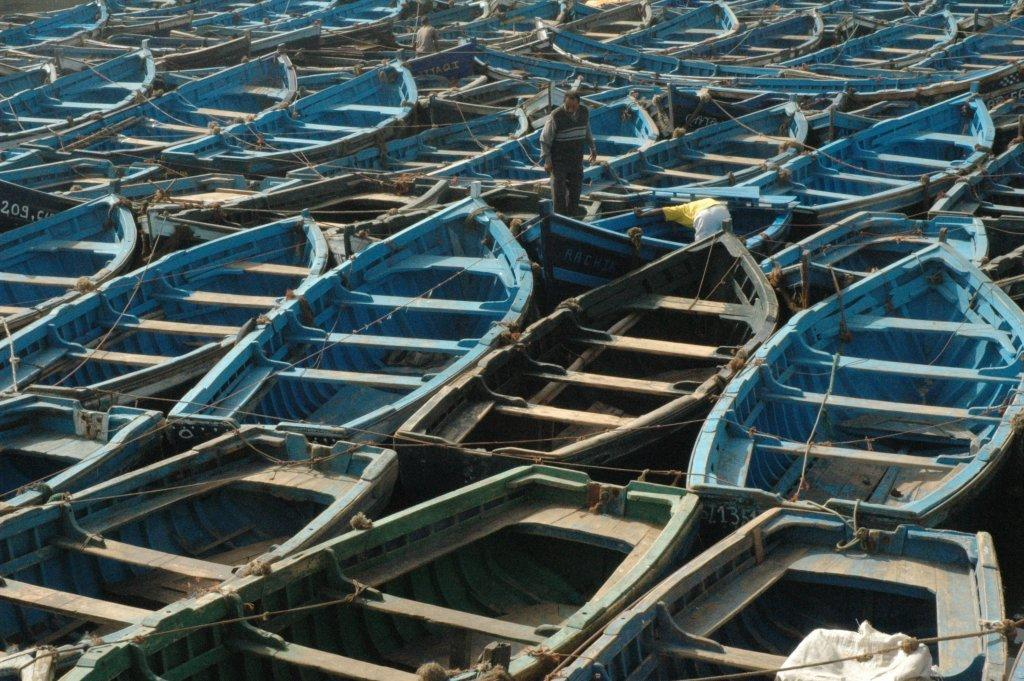What is the main subject of the image? The main subject of the image is many boats. What color are the boats in the image? The boats are blue in color. What material are the boats made of? The boats are made of wood. Can you describe the person in the image? There is a man standing in one of the boats. What note is the boy playing on his instrument in the image? There is no boy or instrument present in the image; it features many blue wooden boats with a man standing in one of them. 